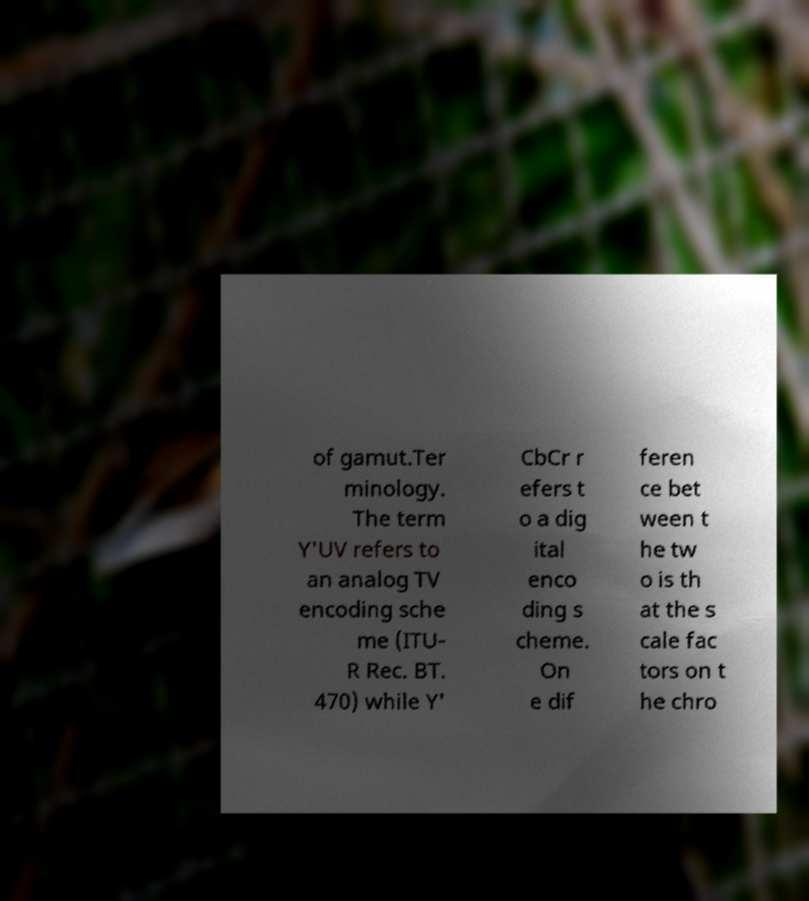Please identify and transcribe the text found in this image. of gamut.Ter minology. The term Y'UV refers to an analog TV encoding sche me (ITU- R Rec. BT. 470) while Y' CbCr r efers t o a dig ital enco ding s cheme. On e dif feren ce bet ween t he tw o is th at the s cale fac tors on t he chro 